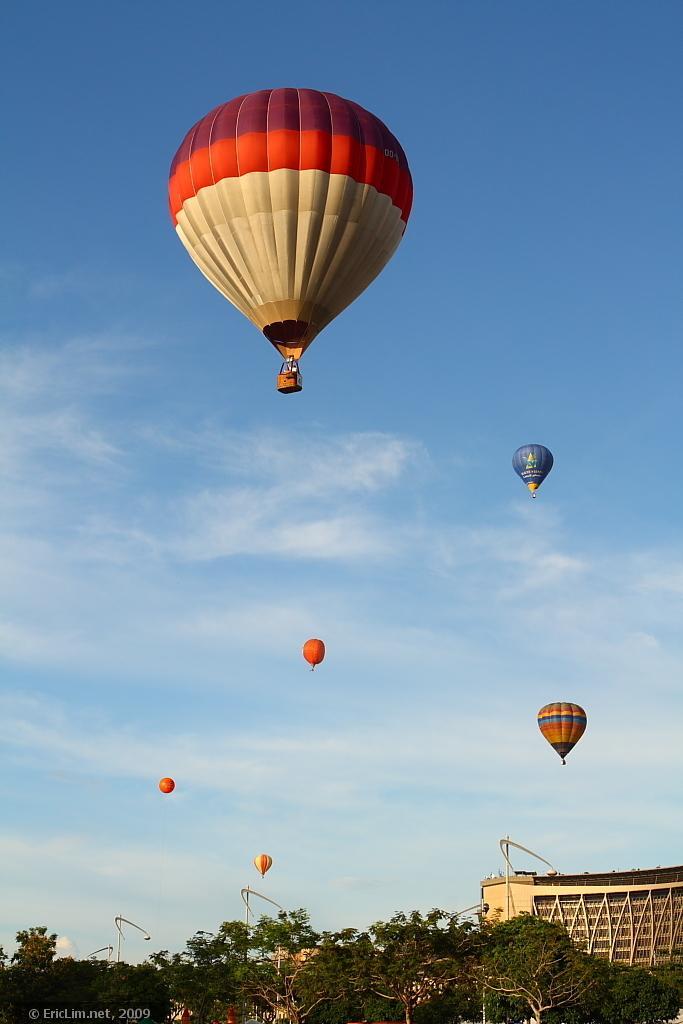In one or two sentences, can you explain what this image depicts? In this picture I can see few hot air balloons and I can see buildings, trees and text at the bottom left corner and I can see blue cloudy sky. 